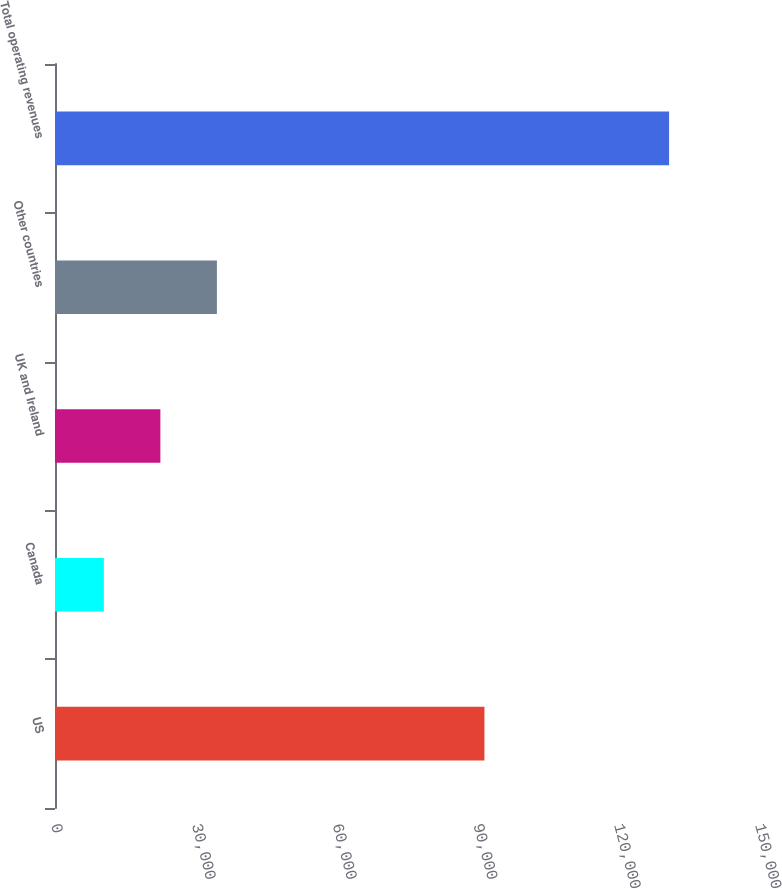Convert chart. <chart><loc_0><loc_0><loc_500><loc_500><bar_chart><fcel>US<fcel>Canada<fcel>UK and Ireland<fcel>Other countries<fcel>Total operating revenues<nl><fcel>91499<fcel>10410<fcel>22453.4<fcel>34496.8<fcel>130844<nl></chart> 